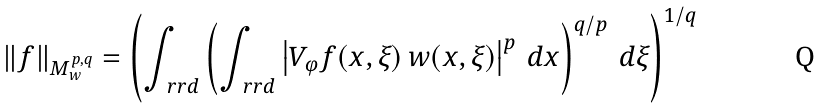Convert formula to latex. <formula><loc_0><loc_0><loc_500><loc_500>\| f \| _ { M _ { w } ^ { p , q } } = \left ( \int _ { \ r r d } \left ( \int _ { \ r r d } \left | V _ { \varphi } f ( x , \xi ) \, w ( x , \xi ) \right | ^ { p } \, d x \right ) ^ { q / p } \, d \xi \right ) ^ { 1 / q }</formula> 